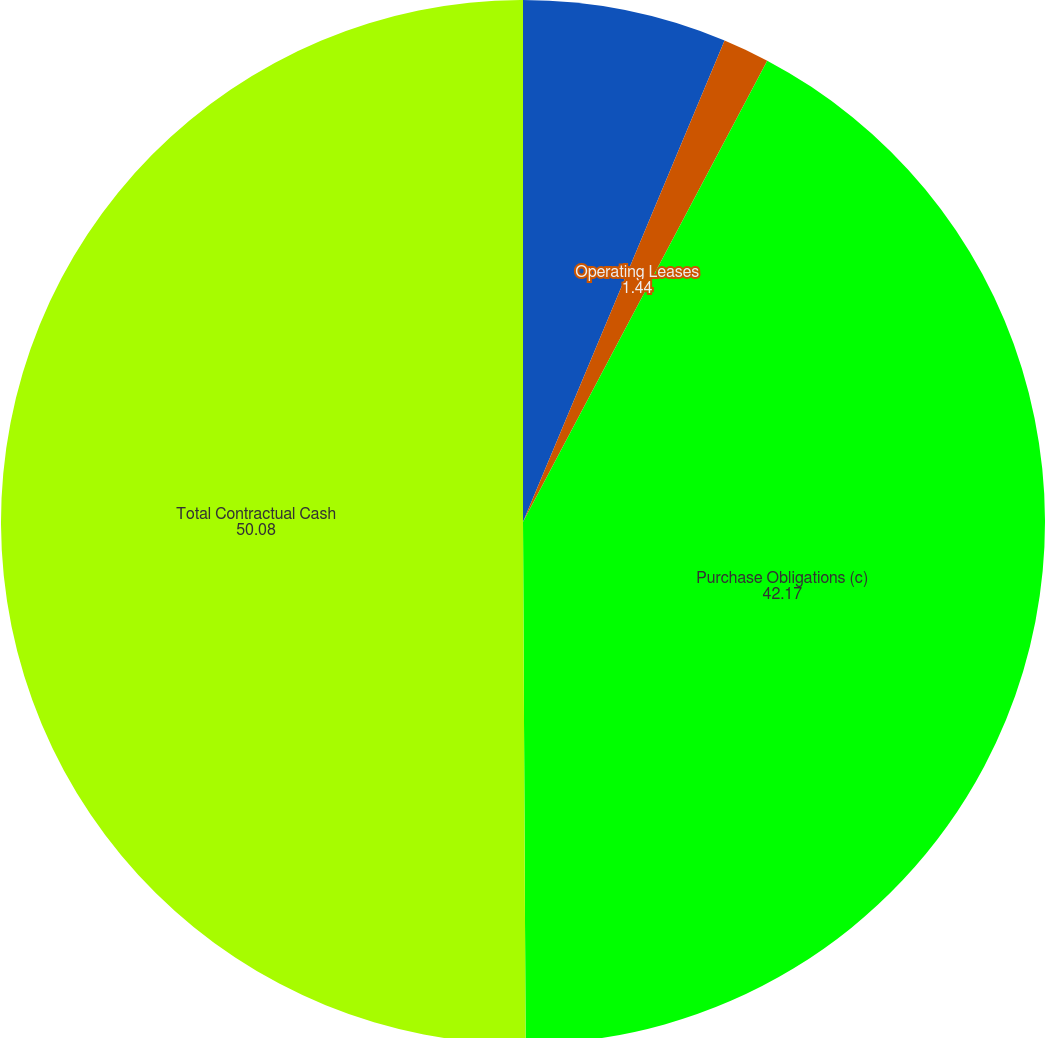<chart> <loc_0><loc_0><loc_500><loc_500><pie_chart><fcel>Interest on Long-term Debt (b)<fcel>Operating Leases<fcel>Purchase Obligations (c)<fcel>Total Contractual Cash<nl><fcel>6.31%<fcel>1.44%<fcel>42.17%<fcel>50.08%<nl></chart> 